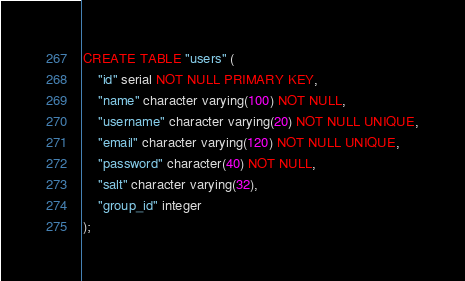Convert code to text. <code><loc_0><loc_0><loc_500><loc_500><_SQL_>CREATE TABLE "users" (
    "id" serial NOT NULL PRIMARY KEY,
    "name" character varying(100) NOT NULL,
    "username" character varying(20) NOT NULL UNIQUE,
    "email" character varying(120) NOT NULL UNIQUE,
    "password" character(40) NOT NULL,
    "salt" character varying(32),
    "group_id" integer
);</code> 